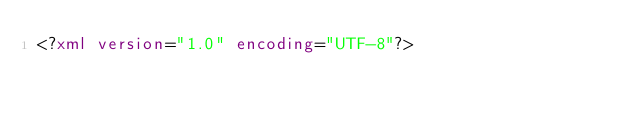Convert code to text. <code><loc_0><loc_0><loc_500><loc_500><_XML_><?xml version="1.0" encoding="UTF-8"?></code> 